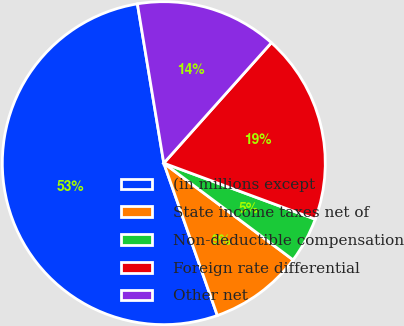Convert chart to OTSL. <chart><loc_0><loc_0><loc_500><loc_500><pie_chart><fcel>(in millions except<fcel>State income taxes net of<fcel>Non-deductible compensation<fcel>Foreign rate differential<fcel>Other net<nl><fcel>52.77%<fcel>9.4%<fcel>4.58%<fcel>19.04%<fcel>14.22%<nl></chart> 